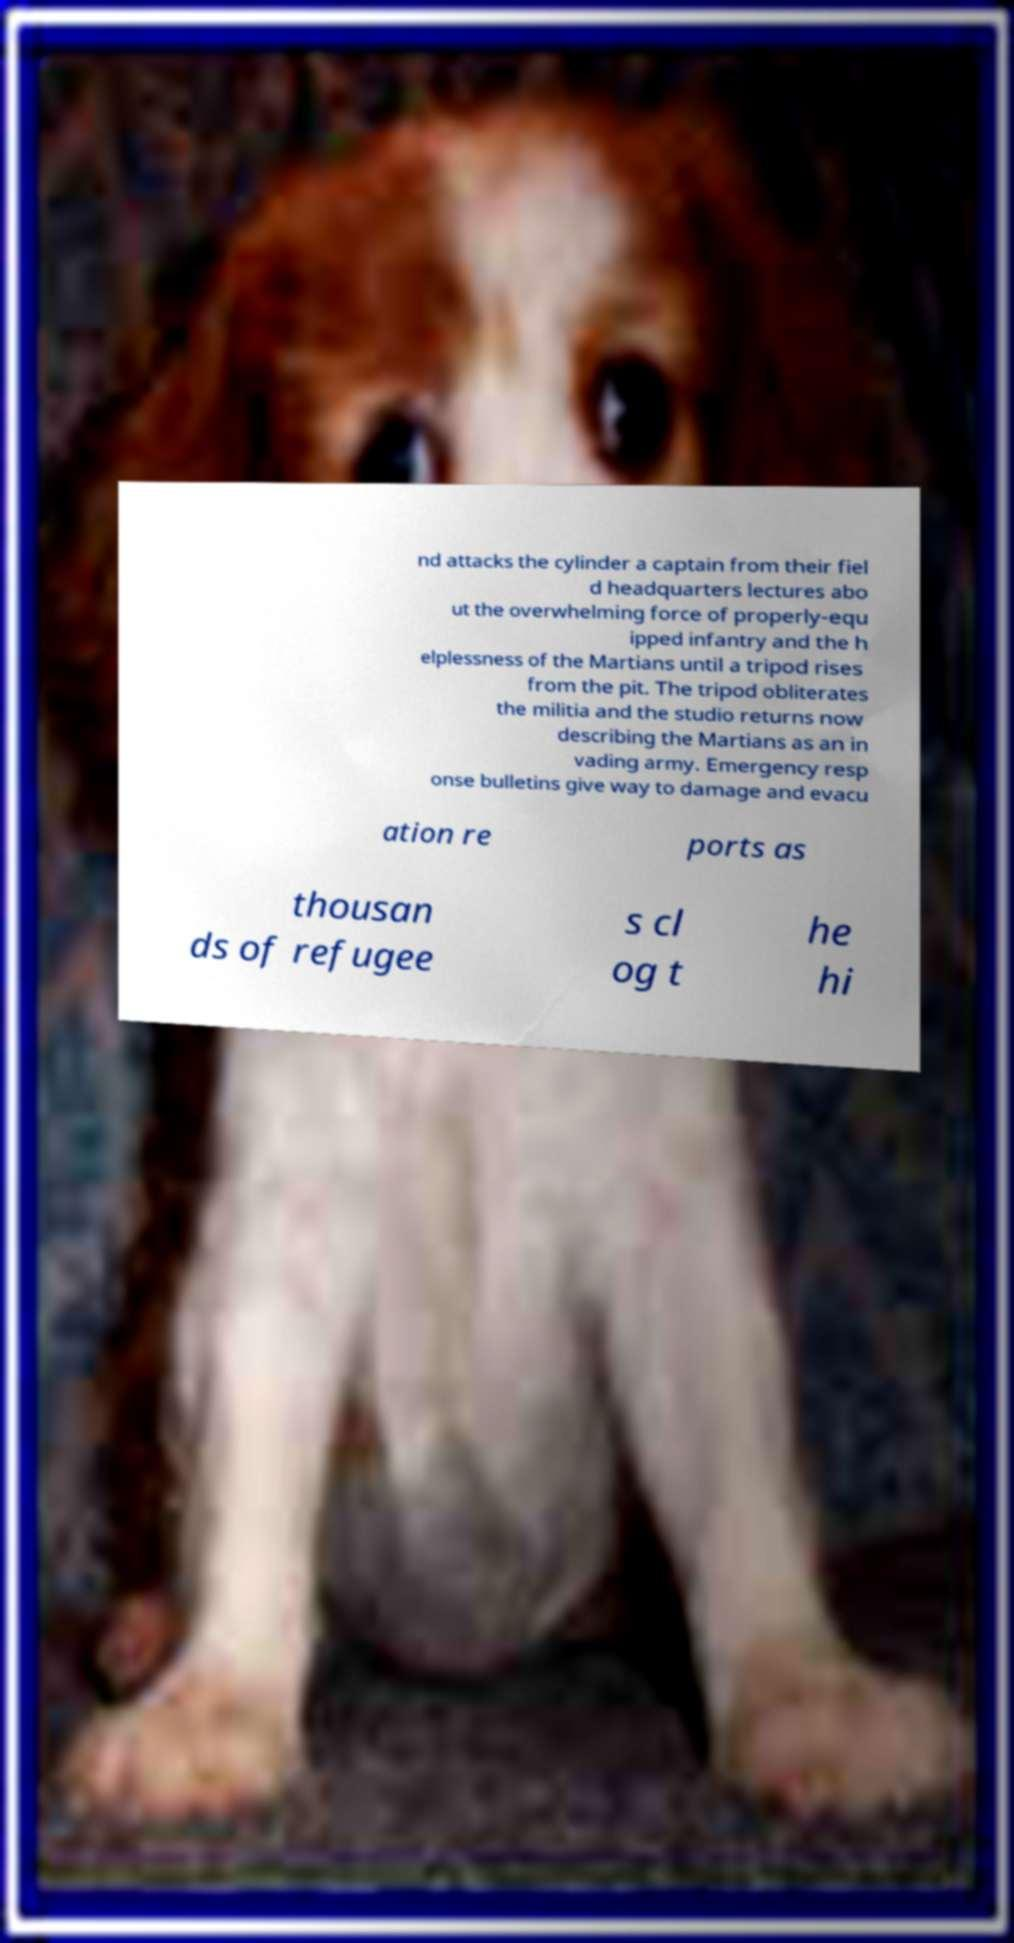I need the written content from this picture converted into text. Can you do that? nd attacks the cylinder a captain from their fiel d headquarters lectures abo ut the overwhelming force of properly-equ ipped infantry and the h elplessness of the Martians until a tripod rises from the pit. The tripod obliterates the militia and the studio returns now describing the Martians as an in vading army. Emergency resp onse bulletins give way to damage and evacu ation re ports as thousan ds of refugee s cl og t he hi 